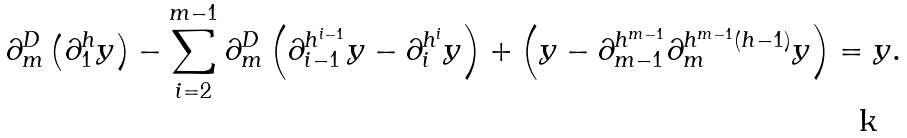<formula> <loc_0><loc_0><loc_500><loc_500>\partial _ { m } ^ { D } \left ( \partial _ { 1 } ^ { h } y \right ) - \sum _ { i = 2 } ^ { m - 1 } \partial _ { m } ^ { D } \left ( \partial _ { i - 1 } ^ { h ^ { i - 1 } } y - \partial _ { i } ^ { h ^ { i } } y \right ) + \left ( y - \partial _ { m - 1 } ^ { h ^ { m - 1 } } \partial _ { m } ^ { h ^ { m - 1 } ( h - 1 ) } y \right ) = y .</formula> 